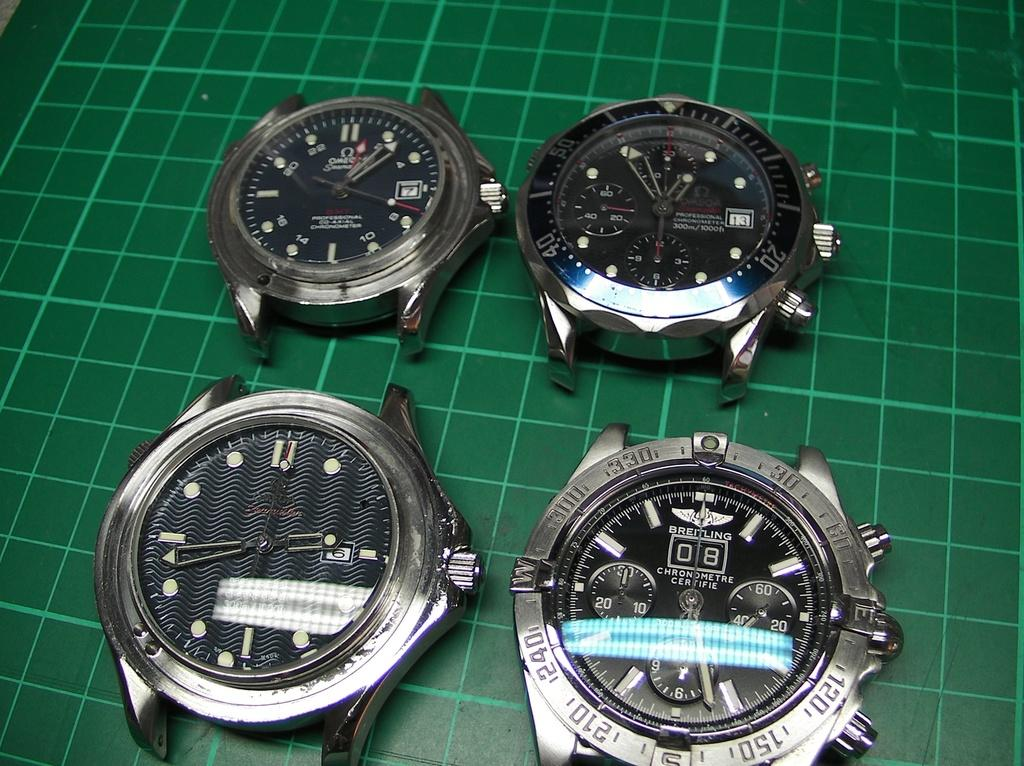<image>
Summarize the visual content of the image. Four watch faces from brands such as Omega and Breitling sit on green graph paper. 